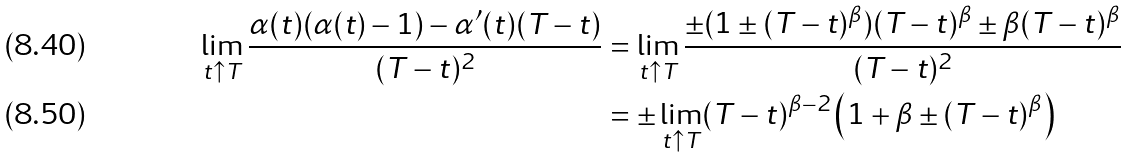Convert formula to latex. <formula><loc_0><loc_0><loc_500><loc_500>\lim _ { t \uparrow T } \frac { \alpha ( t ) ( \alpha ( t ) - 1 ) - \alpha ^ { \prime } ( t ) ( T - t ) } { ( T - t ) ^ { 2 } } & = \lim _ { t \uparrow T } \frac { \pm ( 1 \pm ( T - t ) ^ { \beta } ) ( T - t ) ^ { \beta } \pm \beta ( T - t ) ^ { \beta } } { ( T - t ) ^ { 2 } } \\ & = \pm \lim _ { t \uparrow T } ( T - t ) ^ { \beta - 2 } \left ( 1 + \beta \pm ( T - t ) ^ { \beta } \right )</formula> 